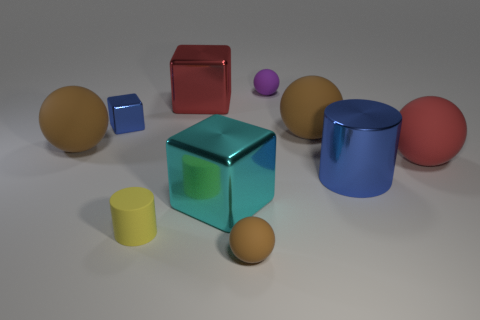Subtract all cyan cylinders. How many brown balls are left? 3 Subtract 2 spheres. How many spheres are left? 3 Subtract all purple balls. How many balls are left? 4 Subtract all red matte balls. How many balls are left? 4 Subtract all gray spheres. Subtract all green cylinders. How many spheres are left? 5 Subtract all cylinders. How many objects are left? 8 Add 3 small yellow cylinders. How many small yellow cylinders exist? 4 Subtract 0 yellow spheres. How many objects are left? 10 Subtract all large rubber things. Subtract all large gray cylinders. How many objects are left? 7 Add 2 red balls. How many red balls are left? 3 